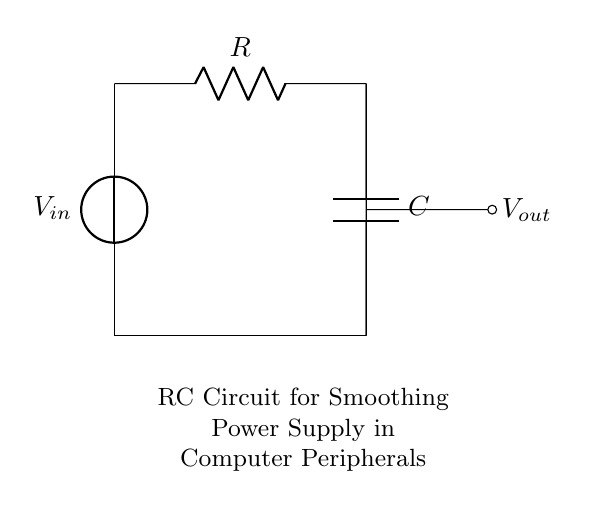What components are in the circuit? The circuit contains a voltage source, a resistor, and a capacitor. These components are identifiable by their symbols in the circuit diagram.
Answer: voltage source, resistor, capacitor What is the function of the capacitor in this circuit? The capacitor smooths out voltage fluctuations, providing a more stable output voltage by storing and releasing charge as needed during operation.
Answer: smoothing voltage fluctuations What does V out represent in this circuit? V out represents the output voltage, which is measured across the capacitor and provides the final voltage to the connected load.
Answer: output voltage What type of circuit is this? This is an RC circuit, specifically designed for filtering or smoothing power supply in electronic devices, utilizing both resistive and capacitive components.
Answer: RC circuit What happens to V out when C charges fully? When the capacitor is fully charged, V out approaches the source voltage, effectively stabilizing the output voltage level for the connected components.
Answer: approaches source voltage How does increasing the resistance affect the time constant of the circuit? Increasing resistance leads to a longer time constant, which means the capacitor charges and discharges more slowly, providing a smoother output voltage over a longer period.
Answer: longer time constant What is the role of R in this circuit configuration? The resistor limits the current flowing into and out of the capacitor, controlling the charging and discharging rate and thereby influencing the overall response time of the circuit.
Answer: limits current 